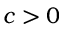<formula> <loc_0><loc_0><loc_500><loc_500>c > 0</formula> 